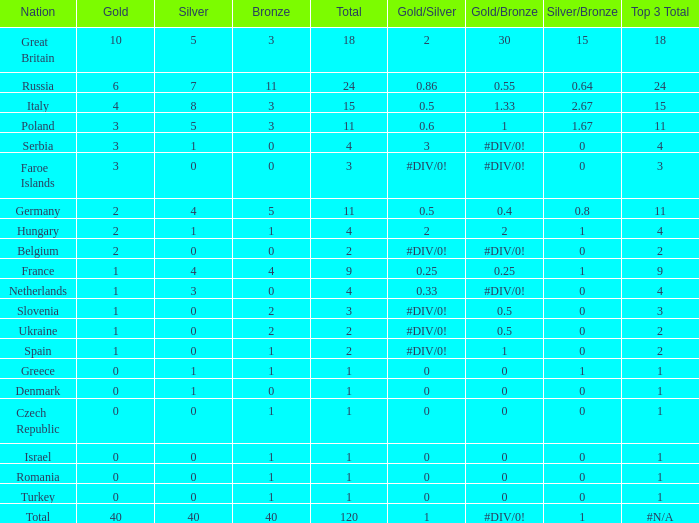What is Turkey's average Gold entry that also has a Bronze entry that is smaller than 2 and the Total is greater than 1? None. 